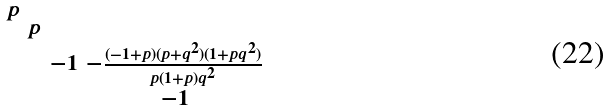<formula> <loc_0><loc_0><loc_500><loc_500>\begin{smallmatrix} p & & & \\ & p & & \\ & & - 1 & - \frac { ( - 1 + p ) ( p + q ^ { 2 } ) ( 1 + p q ^ { 2 } ) } { p ( 1 + p ) q ^ { 2 } } \\ & & & - 1 \end{smallmatrix}</formula> 